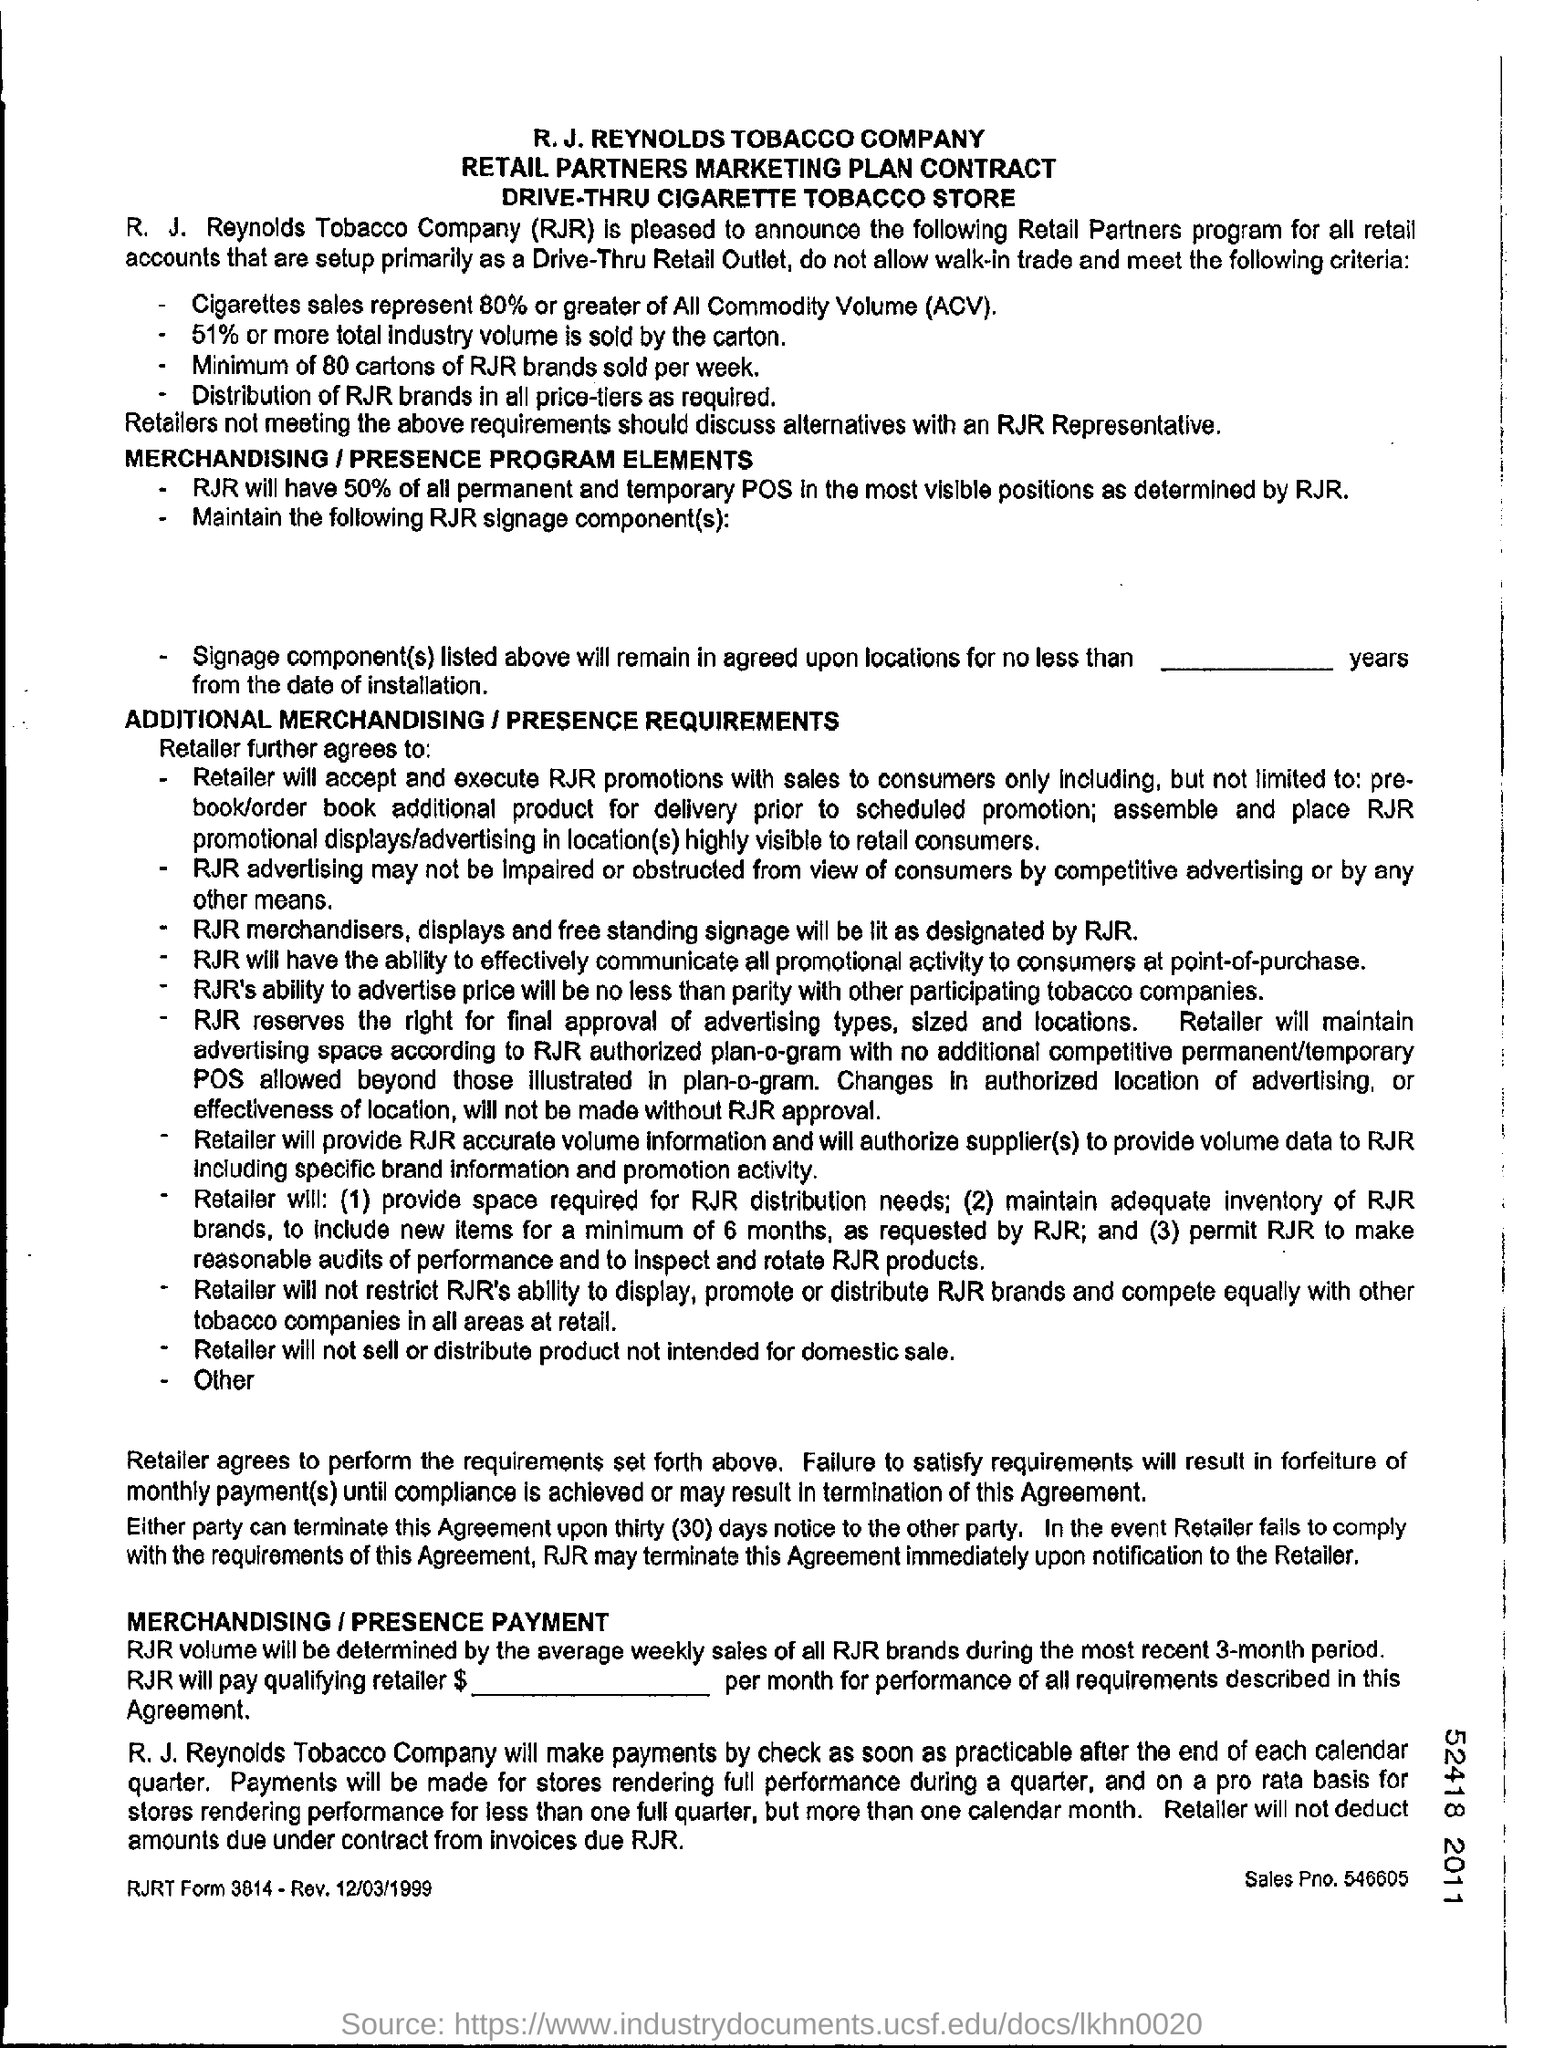Specify some key components in this picture. RJR will have at least 50% of all permanent and temporary Point of Sale (POS) in the most visible positions, as determined by RJR. A significant portion, approximately 51%, of the total industry volume is sold by the carton. R.J. Reynolds Tobacco Company is a company that is commonly referred to as RJR. The sales PNO is 546605... All commodity volume, commonly known as ACV, is a full form that stands for the entirety of a product's quantity traded in a specific market. 